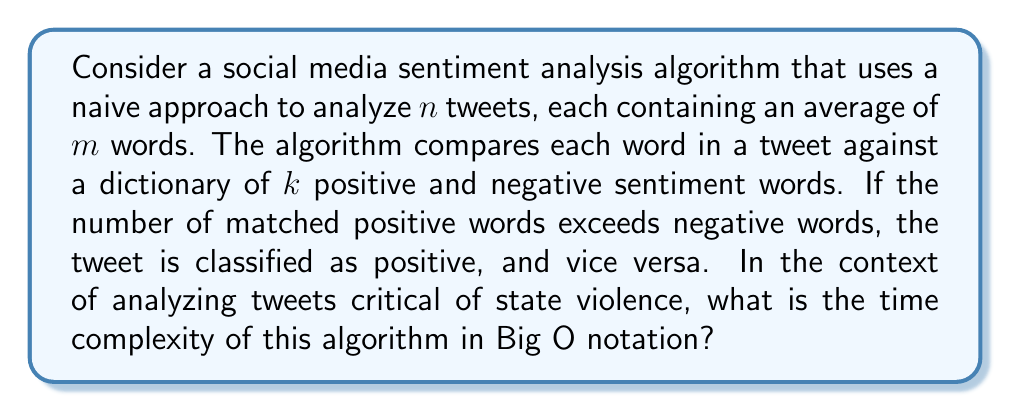Can you solve this math problem? To analyze the time complexity of this algorithm, we need to break it down into steps:

1. For each tweet (there are $n$ tweets):
   a. For each word in the tweet (average of $m$ words per tweet):
      i. Compare the word against each word in the sentiment dictionary (size $k$)

2. The comparison of each word against the dictionary is an $O(k)$ operation, assuming a simple linear search.

3. This comparison is done for each of the $m$ words in a tweet, resulting in $O(m * k)$ operations per tweet.

4. Since this process is repeated for all $n$ tweets, the total time complexity becomes $O(n * m * k)$.

In the context of analyzing tweets critical of state violence, we can assume that:
- $n$ could be very large, as there might be numerous tweets on this topic
- $m$ is relatively small and constant (Twitter has a character limit)
- $k$ is also relatively small and constant (the sentiment dictionary size doesn't grow with input)

Therefore, we can simplify the complexity to $O(n)$, considering $m$ and $k$ as constants.

However, it's important to note that this naive approach is inefficient for large-scale sentiment analysis. More sophisticated algorithms, such as those using machine learning techniques or optimized data structures for the sentiment dictionary, could potentially improve the efficiency.
Answer: The time complexity of the naive social media sentiment analysis algorithm is $O(n * m * k)$, which simplifies to $O(n)$ when considering $m$ and $k$ as constants in the context of analyzing tweets about state violence. 